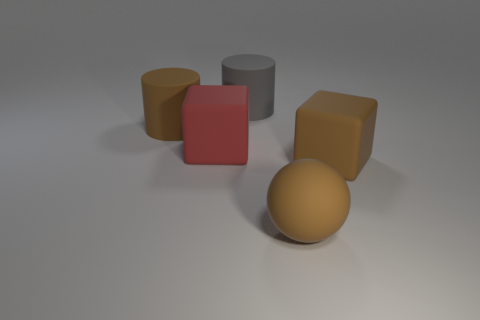Add 2 large brown rubber balls. How many objects exist? 7 Subtract all cylinders. How many objects are left? 3 Subtract all large rubber blocks. Subtract all red blocks. How many objects are left? 2 Add 5 big matte objects. How many big matte objects are left? 10 Add 2 cyan metal things. How many cyan metal things exist? 2 Subtract 0 red cylinders. How many objects are left? 5 